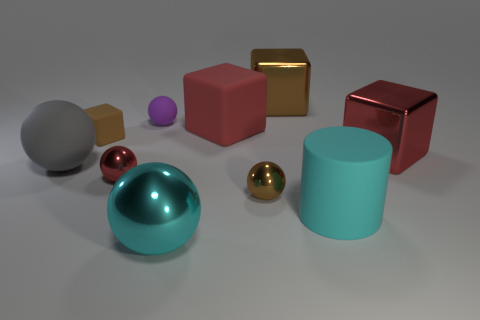Are there any other things that have the same shape as the cyan rubber thing?
Provide a short and direct response. No. Is the number of large red matte blocks that are in front of the purple ball the same as the number of large yellow metal objects?
Your answer should be very brief. No. There is a matte sphere in front of the purple object; does it have the same size as the brown sphere?
Your response must be concise. No. How many red rubber cubes are there?
Offer a terse response. 1. What number of shiny things are to the right of the small brown shiny ball and in front of the tiny brown metallic ball?
Provide a short and direct response. 0. Are there any other objects that have the same material as the purple thing?
Offer a terse response. Yes. There is a tiny brown thing behind the small metallic object that is right of the red rubber cube; what is it made of?
Give a very brief answer. Rubber. Is the number of red matte blocks that are behind the large red matte cube the same as the number of red rubber objects that are in front of the cyan rubber object?
Offer a very short reply. Yes. Is the tiny red thing the same shape as the small purple thing?
Keep it short and to the point. Yes. What is the red thing that is both on the left side of the big cyan rubber cylinder and right of the tiny rubber ball made of?
Your answer should be compact. Rubber. 